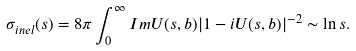Convert formula to latex. <formula><loc_0><loc_0><loc_500><loc_500>\sigma _ { i n e l } ( s ) = 8 \pi \int _ { 0 } ^ { \infty } I m U ( s , b ) | 1 - i U ( s , b ) | ^ { - 2 } \sim \ln s .</formula> 